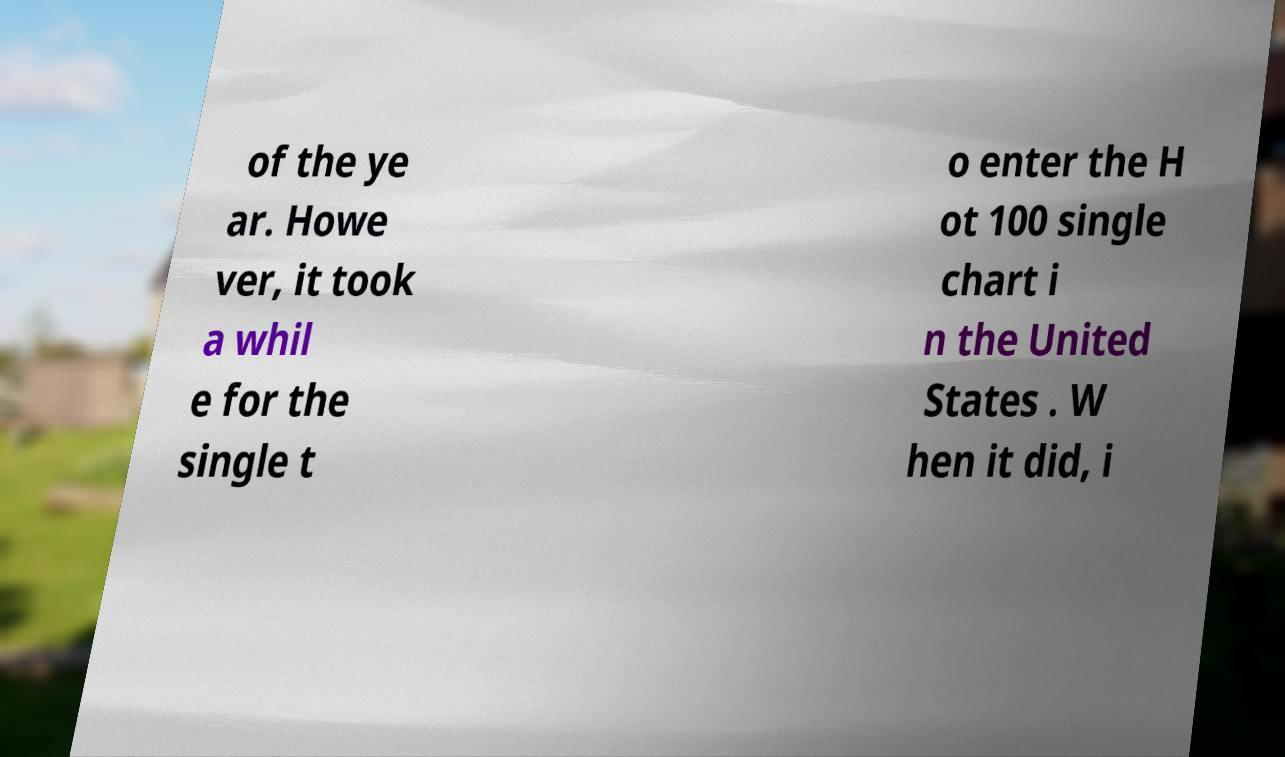Can you accurately transcribe the text from the provided image for me? of the ye ar. Howe ver, it took a whil e for the single t o enter the H ot 100 single chart i n the United States . W hen it did, i 